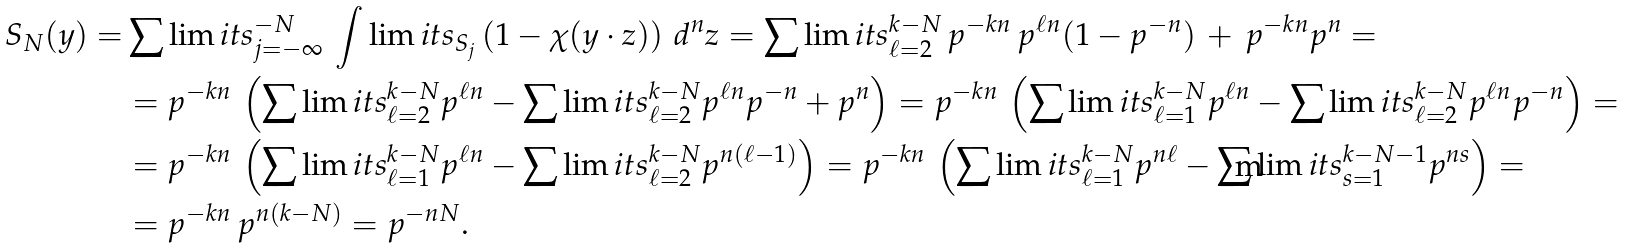Convert formula to latex. <formula><loc_0><loc_0><loc_500><loc_500>S _ { N } ( y ) = & \sum \lim i t s _ { j = - \infty } ^ { - N } \, \int \lim i t s _ { S _ { j } } \left ( 1 - \chi ( y \cdot z ) \right ) \, d ^ { n } z = \sum \lim i t s _ { \ell = 2 } ^ { k - N } \, p ^ { - k n } \, p ^ { \ell n } ( 1 - p ^ { - n } ) \, + \, p ^ { - k n } p ^ { n } = \\ & = p ^ { - k n } \, \left ( \sum \lim i t s _ { \ell = 2 } ^ { k - N } p ^ { \ell n } - \sum \lim i t s _ { \ell = 2 } ^ { k - N } p ^ { \ell n } p ^ { - n } + p ^ { n } \right ) = p ^ { - k n } \, \left ( \sum \lim i t s _ { \ell = 1 } ^ { k - N } p ^ { \ell n } - \sum \lim i t s _ { \ell = 2 } ^ { k - N } p ^ { \ell n } p ^ { - n } \right ) = \\ & = p ^ { - k n } \, \left ( \sum \lim i t s _ { \ell = 1 } ^ { k - N } p ^ { \ell n } - \sum \lim i t s _ { \ell = 2 } ^ { k - N } p ^ { n ( \ell - 1 ) } \right ) = p ^ { - k n } \, \left ( \sum \lim i t s _ { \ell = 1 } ^ { k - N } p ^ { n \ell } - \sum \lim i t s _ { s = 1 } ^ { k - N - 1 } p ^ { n s } \right ) = \\ & = p ^ { - k n } \, p ^ { n ( k - N ) } = p ^ { - n N } .</formula> 